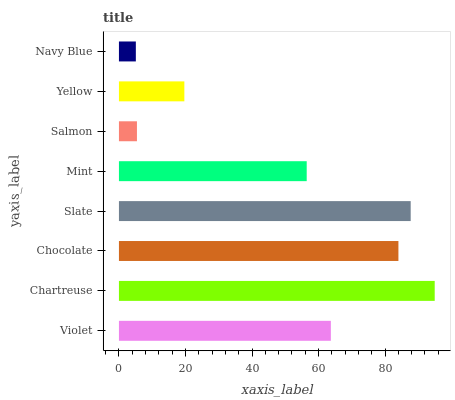Is Navy Blue the minimum?
Answer yes or no. Yes. Is Chartreuse the maximum?
Answer yes or no. Yes. Is Chocolate the minimum?
Answer yes or no. No. Is Chocolate the maximum?
Answer yes or no. No. Is Chartreuse greater than Chocolate?
Answer yes or no. Yes. Is Chocolate less than Chartreuse?
Answer yes or no. Yes. Is Chocolate greater than Chartreuse?
Answer yes or no. No. Is Chartreuse less than Chocolate?
Answer yes or no. No. Is Violet the high median?
Answer yes or no. Yes. Is Mint the low median?
Answer yes or no. Yes. Is Slate the high median?
Answer yes or no. No. Is Navy Blue the low median?
Answer yes or no. No. 